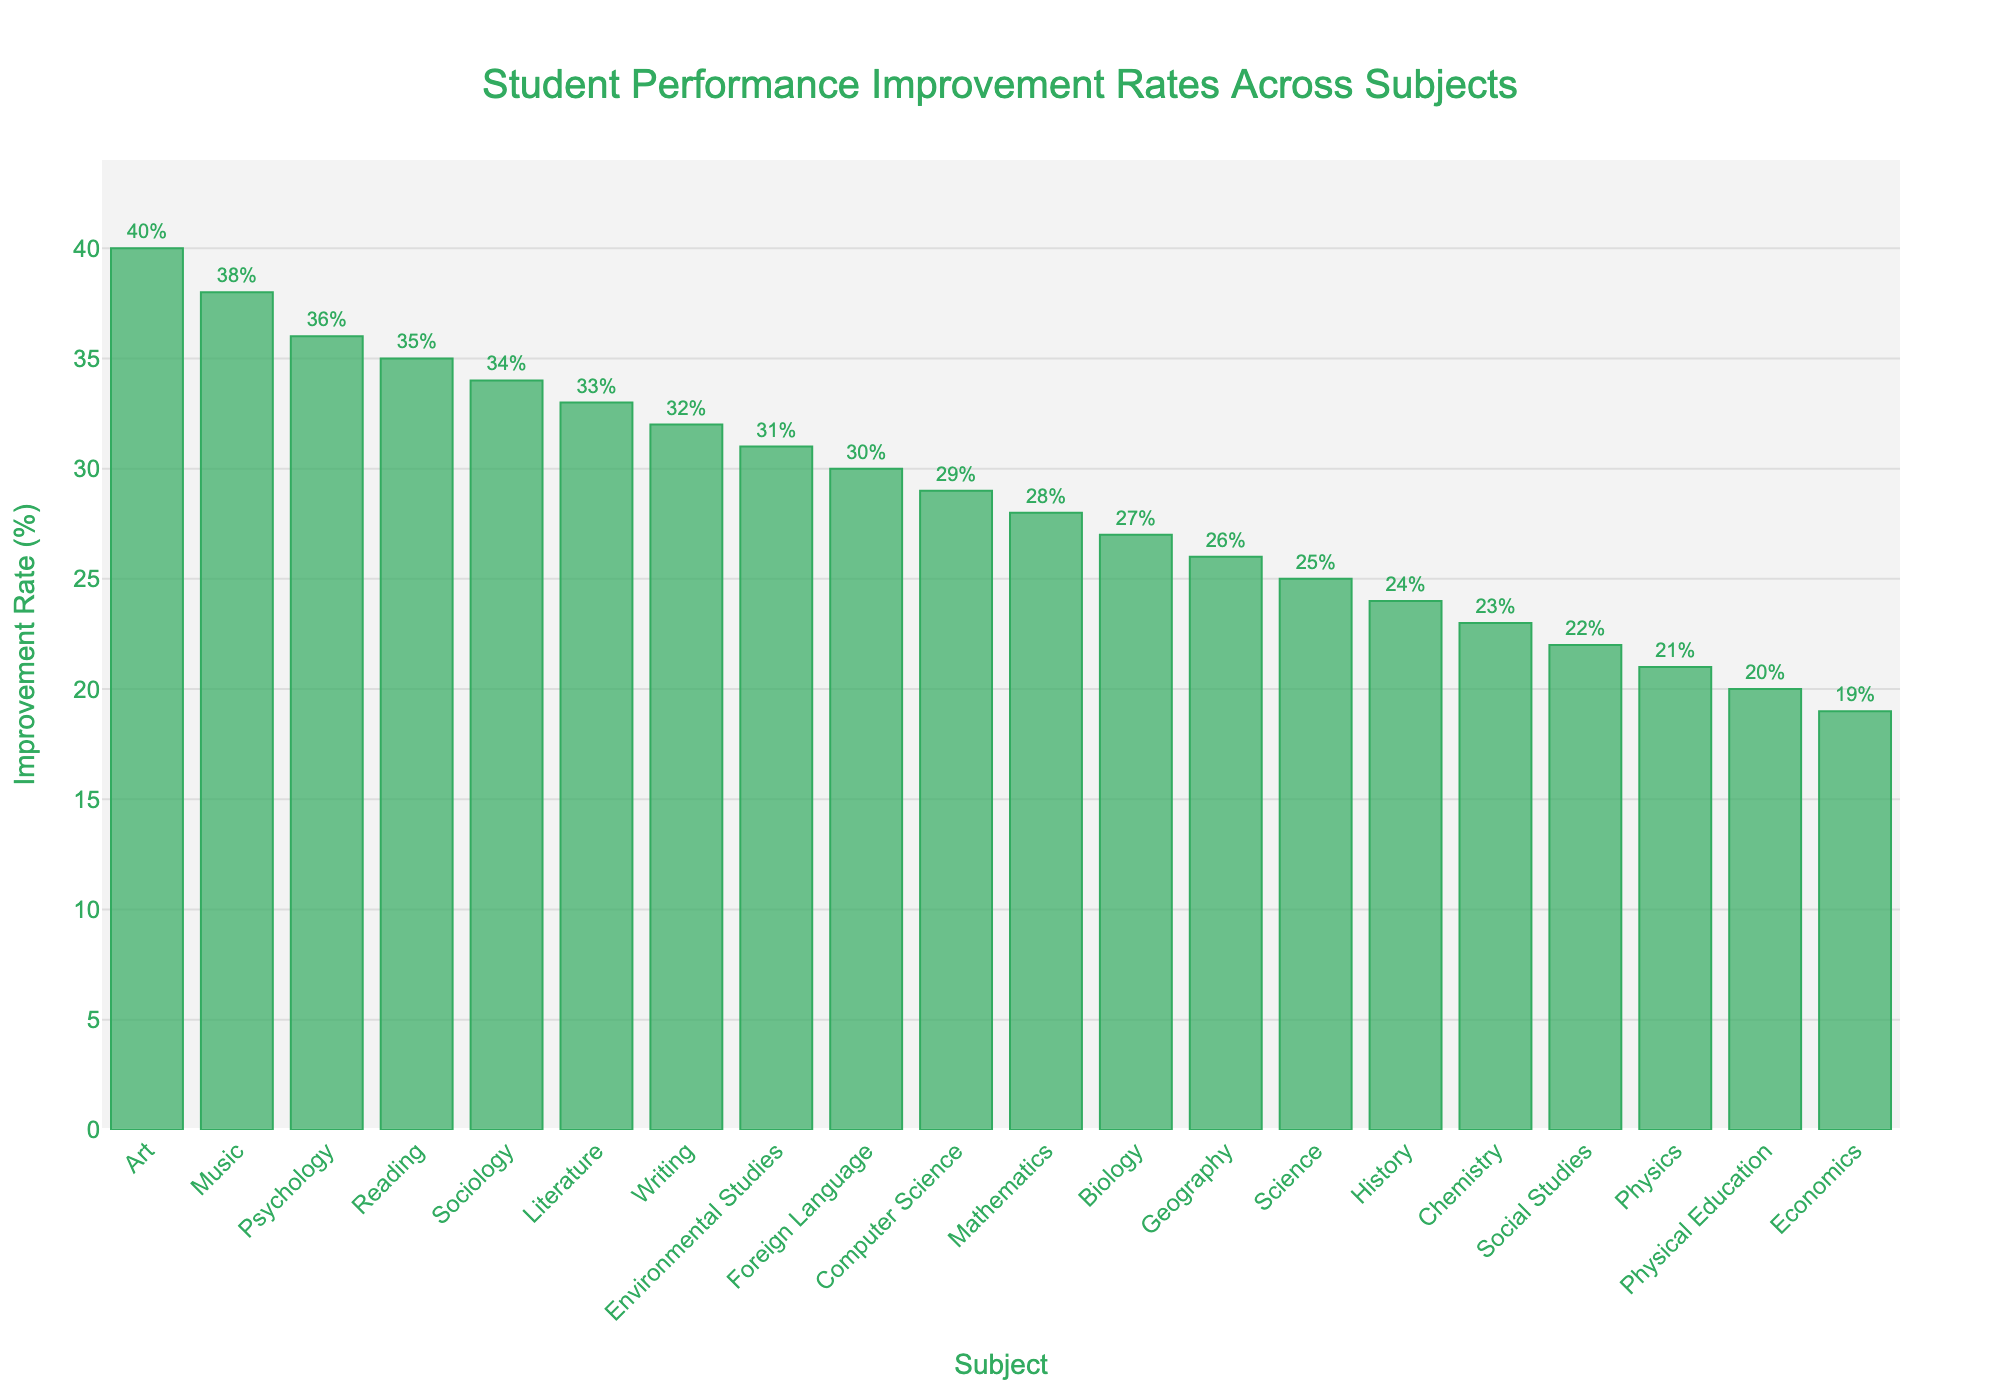Which subject had the highest improvement rate? By visually inspecting the length of the bars in the figure, the bar representing "Art" is the highest.
Answer: Art What is the difference in improvement rate between the subject with the highest and lowest rates? The improvement rate for "Art" (the highest) is 40%, and for "Economics" (the lowest) is 19%. The difference is 40% - 19%.
Answer: 21% What is the average improvement rate for Mathematics, Reading, and Writing? The improvement rates for Mathematics, Reading, and Writing are 28%, 35%, and 32%, respectively. Calculate the average: (28 + 35 + 32) / 3.
Answer: 31.67% How many subjects have an improvement rate of 30% or more? Count the number of bars that reach at least the 30% mark. These are Mathematics, Reading, Writing, Foreign Language, Art, Music, Literature, Environmental Studies, Psychology, and Sociology.
Answer: 10 Which subjects have an improvement rate less than 25% but more than 20%? Identify the bars with heights in this range. These are History, Physics, and Chemistry.
Answer: History, Physics, Chemistry Is the improvement rate for Computer Science higher than Geography? Visually compare the height of the bars for Computer Science and Geography. Computer Science has a higher improvement rate.
Answer: Yes What is the median improvement rate across all subjects? Arrange the improvement rates in ascending order and find the middle value. The ordered rates are 19, 20, 21, 22, 23, 24, 25, 26, 27, 28, 29, 30, 31, 32, 33, 34, 35, 36, 38, 40. With 20 values, the median is the average of the 10th and 11th values: (28 + 29) / 2.
Answer: 28.5% What is the total improvement rate for Science and Environmental Studies combined? The improvement rates for Science and Environmental Studies are 25% and 31%, respectively. Sum them: 25 + 31.
Answer: 56% Compare the improvement rate for Music and Physical Education. Visually compare the lengths of the bars for Music and Physical Education. Music has a higher improvement rate (38%) compared to Physical Education (20%).
Answer: Music has a higher rate Does any subject have an improvement rate exactly at the average rate of all subjects? Calculate the average rate of all subjects and check if any bar matches this value. The sum of all improvement rates is 529%, and there are 20 subjects, so the average is 529 / 20 = 26.45%. No subject has this exact rate.
Answer: No 